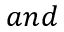Convert formula to latex. <formula><loc_0><loc_0><loc_500><loc_500>a n d</formula> 